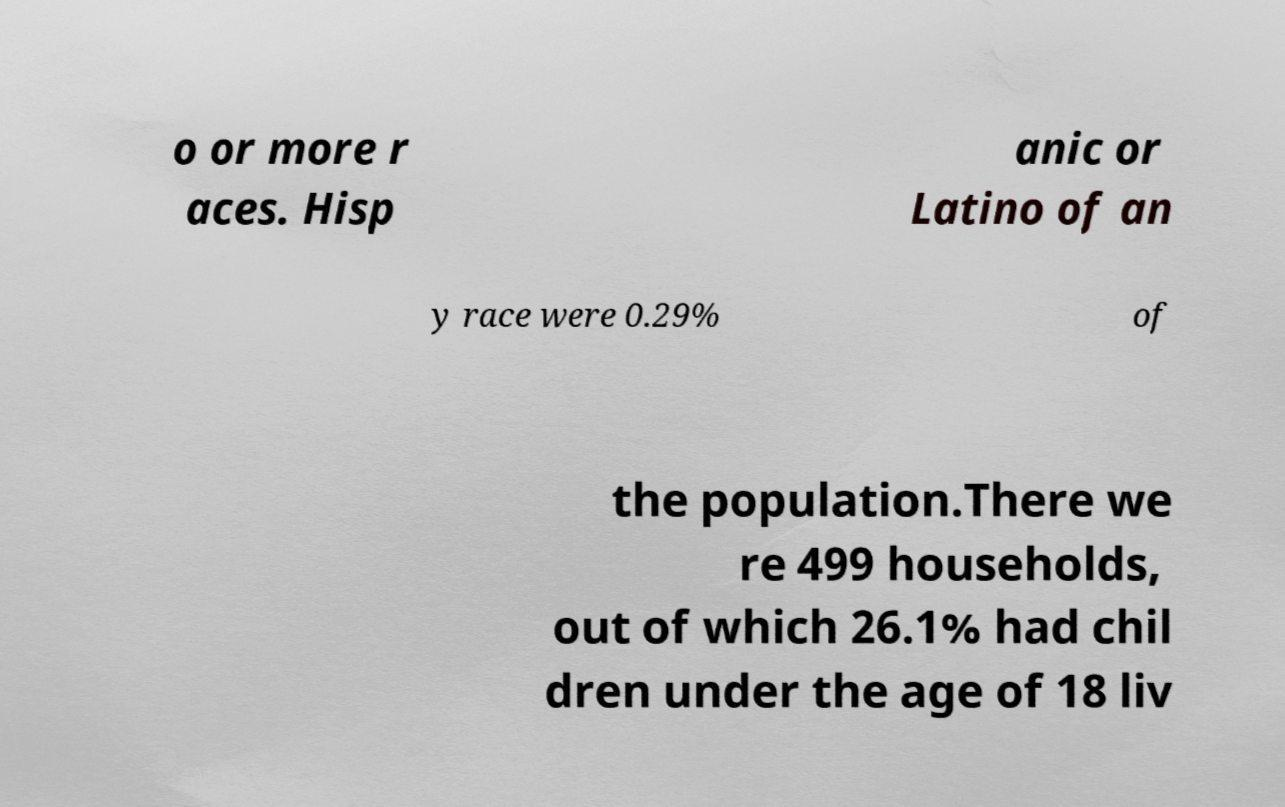Could you assist in decoding the text presented in this image and type it out clearly? o or more r aces. Hisp anic or Latino of an y race were 0.29% of the population.There we re 499 households, out of which 26.1% had chil dren under the age of 18 liv 